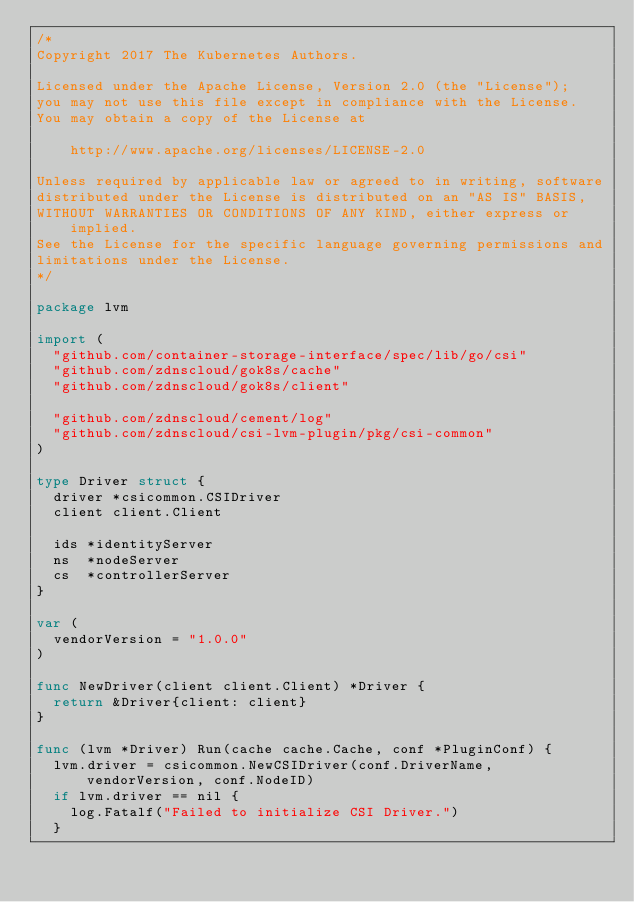<code> <loc_0><loc_0><loc_500><loc_500><_Go_>/*
Copyright 2017 The Kubernetes Authors.

Licensed under the Apache License, Version 2.0 (the "License");
you may not use this file except in compliance with the License.
You may obtain a copy of the License at

    http://www.apache.org/licenses/LICENSE-2.0

Unless required by applicable law or agreed to in writing, software
distributed under the License is distributed on an "AS IS" BASIS,
WITHOUT WARRANTIES OR CONDITIONS OF ANY KIND, either express or implied.
See the License for the specific language governing permissions and
limitations under the License.
*/

package lvm

import (
	"github.com/container-storage-interface/spec/lib/go/csi"
	"github.com/zdnscloud/gok8s/cache"
	"github.com/zdnscloud/gok8s/client"

	"github.com/zdnscloud/cement/log"
	"github.com/zdnscloud/csi-lvm-plugin/pkg/csi-common"
)

type Driver struct {
	driver *csicommon.CSIDriver
	client client.Client

	ids *identityServer
	ns  *nodeServer
	cs  *controllerServer
}

var (
	vendorVersion = "1.0.0"
)

func NewDriver(client client.Client) *Driver {
	return &Driver{client: client}
}

func (lvm *Driver) Run(cache cache.Cache, conf *PluginConf) {
	lvm.driver = csicommon.NewCSIDriver(conf.DriverName, vendorVersion, conf.NodeID)
	if lvm.driver == nil {
		log.Fatalf("Failed to initialize CSI Driver.")
	}
</code> 